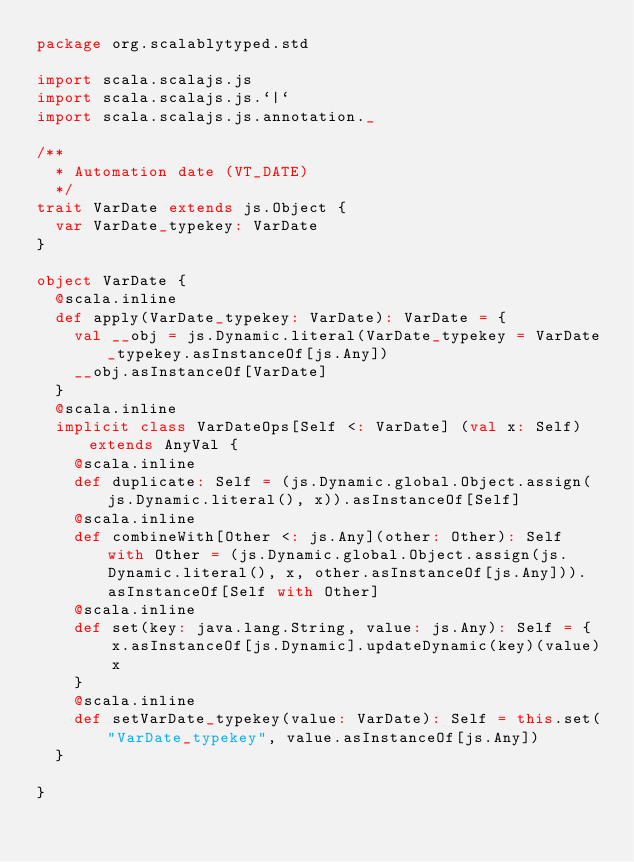Convert code to text. <code><loc_0><loc_0><loc_500><loc_500><_Scala_>package org.scalablytyped.std

import scala.scalajs.js
import scala.scalajs.js.`|`
import scala.scalajs.js.annotation._

/**
  * Automation date (VT_DATE)
  */
trait VarDate extends js.Object {
  var VarDate_typekey: VarDate
}

object VarDate {
  @scala.inline
  def apply(VarDate_typekey: VarDate): VarDate = {
    val __obj = js.Dynamic.literal(VarDate_typekey = VarDate_typekey.asInstanceOf[js.Any])
    __obj.asInstanceOf[VarDate]
  }
  @scala.inline
  implicit class VarDateOps[Self <: VarDate] (val x: Self) extends AnyVal {
    @scala.inline
    def duplicate: Self = (js.Dynamic.global.Object.assign(js.Dynamic.literal(), x)).asInstanceOf[Self]
    @scala.inline
    def combineWith[Other <: js.Any](other: Other): Self with Other = (js.Dynamic.global.Object.assign(js.Dynamic.literal(), x, other.asInstanceOf[js.Any])).asInstanceOf[Self with Other]
    @scala.inline
    def set(key: java.lang.String, value: js.Any): Self = {
        x.asInstanceOf[js.Dynamic].updateDynamic(key)(value)
        x
    }
    @scala.inline
    def setVarDate_typekey(value: VarDate): Self = this.set("VarDate_typekey", value.asInstanceOf[js.Any])
  }
  
}

</code> 